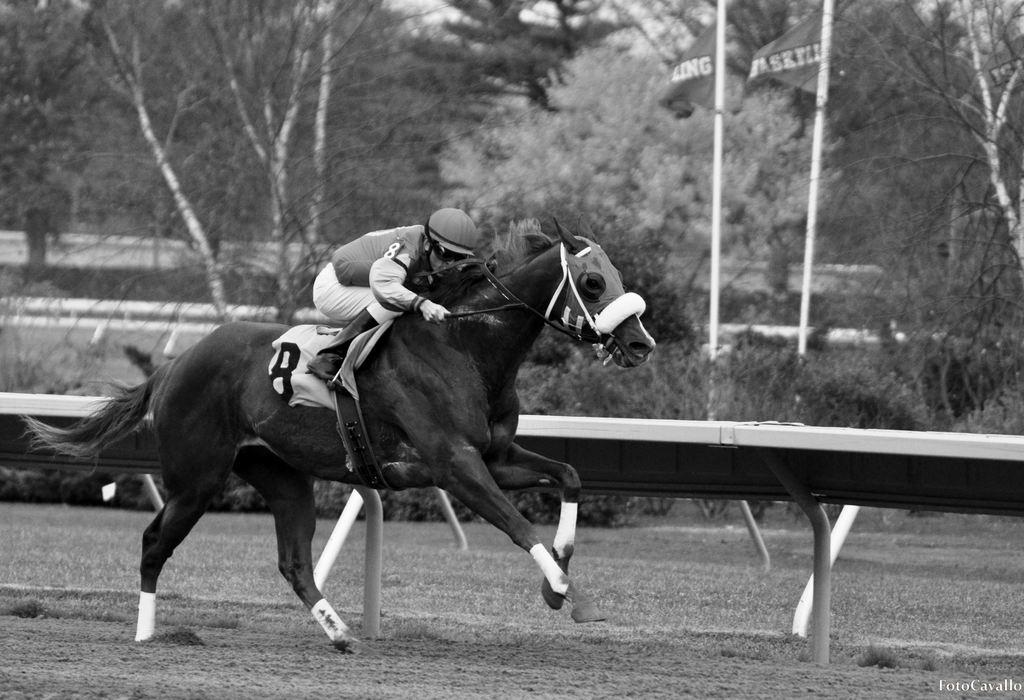What is the main subject of the image? There is a person riding a horse in the image. What can be seen in the background of the image? There is a bench, a pole, a tree, and a flag in the background of the image. What type of drum can be heard playing in the background of the image? There is no drum present or audible in the image. Is there any indication of a protest happening in the image? There is no indication of a protest in the image; it features a person riding a horse with various background elements. 